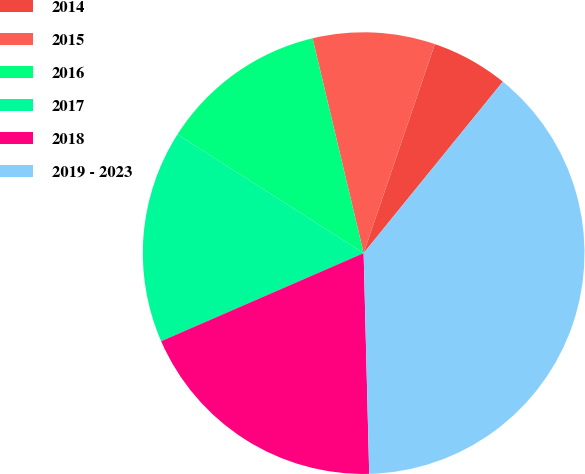Convert chart. <chart><loc_0><loc_0><loc_500><loc_500><pie_chart><fcel>2014<fcel>2015<fcel>2016<fcel>2017<fcel>2018<fcel>2019 - 2023<nl><fcel>5.63%<fcel>8.94%<fcel>12.25%<fcel>15.56%<fcel>18.87%<fcel>38.74%<nl></chart> 